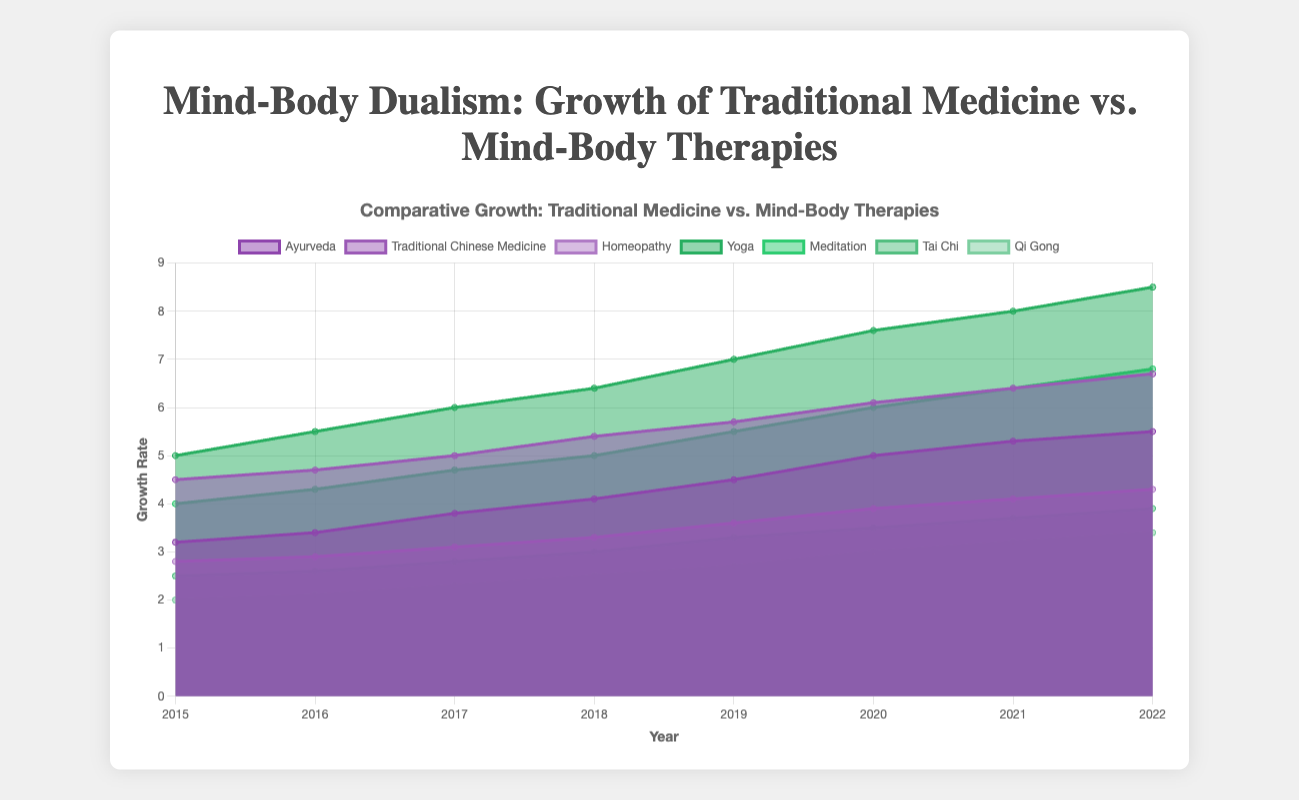What is the title of the chart? The title is displayed at the top of the chart. It provides a summary of what the chart is about.
Answer: Mind-Body Dualism: Growth of Traditional Medicine vs. Mind-Body Therapies What are the labels on the x-axis and y-axis? The labels on the axes represent what the data points correlate to on the chart. The x-axis shows the progression of years while the y-axis indicates growth rate.
Answer: Year, Growth Rate Which therapy has the highest growth rate in 2022? To determine this, we observe all lines at the 2022 mark on the x-axis and identify the one that reaches the highest value on the y-axis.
Answer: Yoga How has the growth of Ayurveda changed from 2015 to 2022? By tracking the line associated with Ayurveda from 2015 to 2022, we can see the change in its growth rate, which increases continuously from 3.2 to 5.5.
Answer: It has increased Which therapy experienced the most consistent growth from 2015 to 2022? Consistent growth implies a steady rate of increase each year. By comparing all the lines, Yoga shows uniform incremental growth without major deviations.
Answer: Yoga What was the growth rate difference between Traditional Chinese Medicine and Qi Gong in 2020? Locate the growth rates for both therapies in 2020 and subtract Qi Gong's rate from Traditional Chinese Medicine's rate.
Answer: 6.1 - 3.0 = 3.1 Compare the growth of Homeopathy and Tai Chi over the given years. Which had a greater overall increase? Calculate the total growth for both therapies from 2015 to 2022 by subtracting the initial value in 2015 from the final value in 2022 and compare the results. Homeopathy: 4.3 - 2.8 = 1.5, Tai Chi: 3.9 - 2.5 = 1.4.
Answer: Homeopathy Which therapy had the lowest growth rate in 2015? Find the lowest point on the y-axis that corresponds to a value in 2015 across all the therapies.
Answer: Qi Gong How did Meditation's growth rate in 2018 compare to its growth rate in 2016? Identify Meditation's growth rates in the specified years from the chart and compare the values. 2016: 4.3, 2018: 5.0.
Answer: It increased What is the average growth rate of Traditional Chinese Medicine between 2015 and 2022? Add the annual growth rates for Traditional Chinese Medicine from 2015 to 2022, then divide by the number of years to find the average. (4.5 + 4.7 + 5.0 + 5.4 + 5.7 + 6.1 + 6.4 + 6.7) / 8 = 5.56
Answer: 5.56 